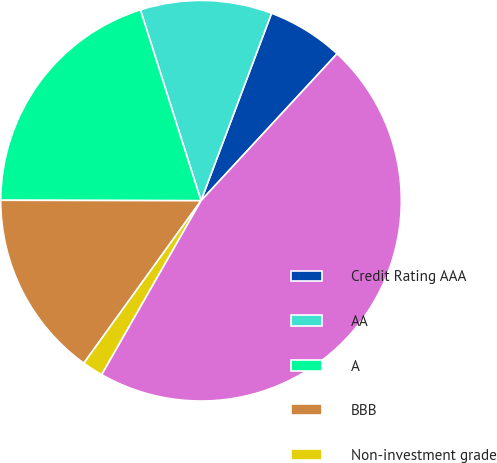<chart> <loc_0><loc_0><loc_500><loc_500><pie_chart><fcel>Credit Rating AAA<fcel>AA<fcel>A<fcel>BBB<fcel>Non-investment grade<fcel>Total<nl><fcel>6.16%<fcel>10.62%<fcel>20.07%<fcel>15.09%<fcel>1.69%<fcel>46.37%<nl></chart> 